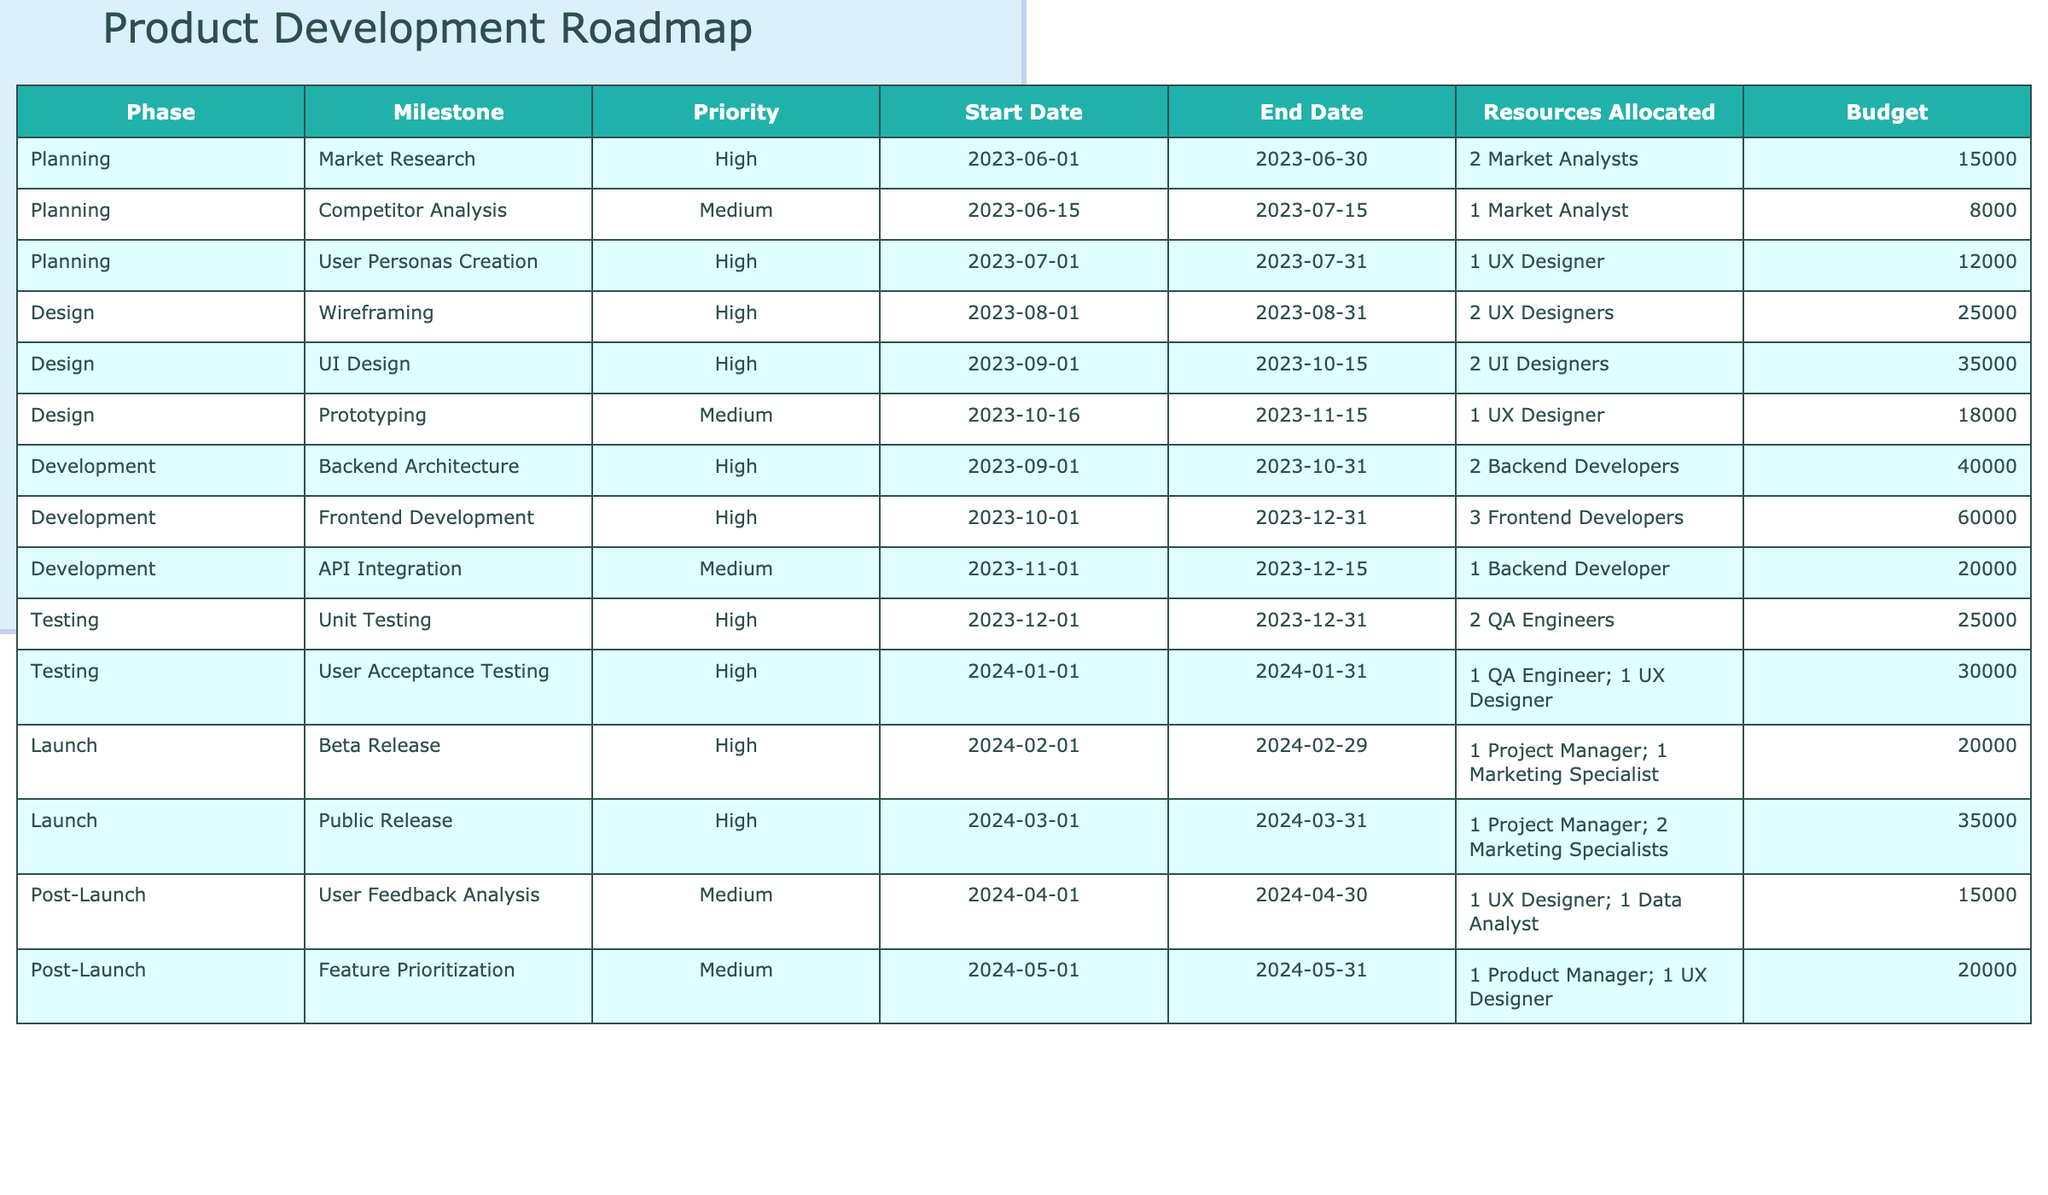What is the total budget allocated for the Planning phase? To find the total budget for the Planning phase, I will sum the budget entries for all milestones under this phase: 15000 (Market Research) + 8000 (Competitor Analysis) + 12000 (User Personas Creation) = 35000.
Answer: 35000 Which milestone has the highest budget allocated? By checking each milestone's budget, UI Design has the highest budget at 35000, compared to others.
Answer: 35000 How many total resources are allocated for the Development phase? The Development phase has the following resources: 2 Backend Developers (for Backend Architecture), 3 Frontend Developers (for Frontend Development), and 1 Backend Developer (for API Integration), totaling 2 + 3 + 1 = 6.
Answer: 6 Is the User Acceptance Testing milestone of high priority? Yes, the User Acceptance Testing milestone is categorized as having high priority, as indicated in the table.
Answer: Yes What is the average budget for the Design phase? The total budget for the Design phase is 25000 (Wireframing) + 35000 (UI Design) + 18000 (Prototyping) = 78000. There are 3 milestones, so the average budget is 78000 / 3 = 26000.
Answer: 26000 How does the budget for the Post-Launch phase compare to the Planning phase? The total budget for the Post-Launch phase is 15000 (User Feedback Analysis) + 20000 (Feature Prioritization) = 35000, while the Planning phase also has a total budget of 35000. Since both total budgets are equal, they are the same.
Answer: They are the same What proportion of the total budget does the Backend Architecture milestone represent? The budget for Backend Architecture is 40000. The total budget for all milestones is 15000 + 8000 + 12000 + 25000 + 35000 + 18000 + 40000 + 60000 + 20000 + 25000 + 30000 + 20000 + 35000 + 15000 + 20000 = 315000. To find the proportion, I divide 40000 by 315000, which equals approximately 0.127 or 12.7%.
Answer: 12.7% What is the total number of milestones with high priority? There are 8 milestones marked with high priority: Market Research, User Personas Creation, Wireframing, UI Design, Backend Architecture, Frontend Development, Unit Testing, and User Acceptance Testing.
Answer: 8 Which phase has the longest duration between its start and end dates? I'll calculate the duration for each phase: Planning (30 days), Design (75 days), Development (61 days), Testing (31 days), Launch (59 days), and Post-Launch (30 days). The longest duration is for the Design phase with a total of 75 days.
Answer: Design phase What is the total number of resources allocated across all phases? I will sum the resources allocated for each phase. In total: 2 (Planning) + 1 + 1 (Planning) + 2 (Design) + 2 (Design) + 1 (Design) + 2 (Development) + 3 (Development) + 1 (Development) + 2 (Testing) + 2 (Testing) + 1 (Launch) + 2 (Launch) + 1 (Post-Launch) + 1 (Post-Launch) = 20.
Answer: 20 